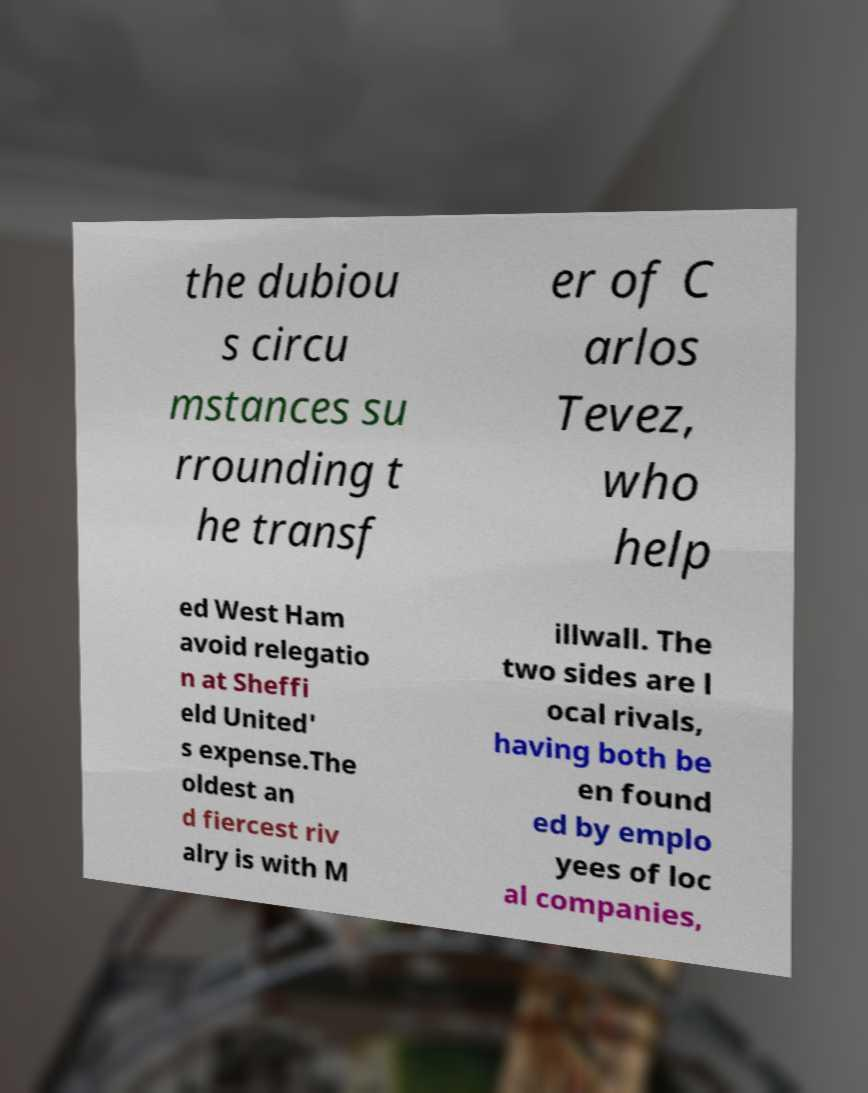For documentation purposes, I need the text within this image transcribed. Could you provide that? the dubiou s circu mstances su rrounding t he transf er of C arlos Tevez, who help ed West Ham avoid relegatio n at Sheffi eld United' s expense.The oldest an d fiercest riv alry is with M illwall. The two sides are l ocal rivals, having both be en found ed by emplo yees of loc al companies, 